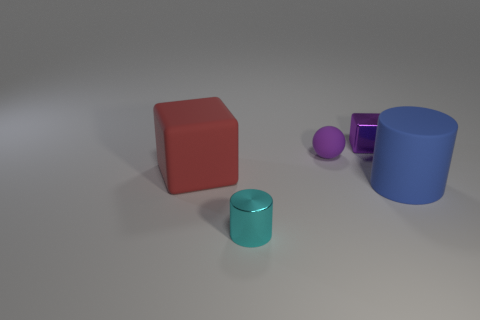Is there anything else that is the same shape as the small matte object?
Ensure brevity in your answer.  No. There is a small metallic thing behind the big cylinder; is its shape the same as the blue object?
Make the answer very short. No. How many cyan metal cylinders have the same size as the metallic block?
Offer a terse response. 1. How many blue matte cylinders are on the right side of the cube that is right of the tiny cyan shiny object?
Keep it short and to the point. 1. Is the thing that is in front of the matte cylinder made of the same material as the blue thing?
Ensure brevity in your answer.  No. Is the material of the cylinder that is in front of the blue cylinder the same as the small thing that is behind the small rubber thing?
Ensure brevity in your answer.  Yes. Is the number of things that are on the right side of the tiny cyan object greater than the number of small cyan things?
Provide a short and direct response. Yes. There is a large rubber object that is to the left of the cylinder that is in front of the blue matte object; what color is it?
Your answer should be very brief. Red. There is a purple metal object that is the same size as the cyan metal thing; what shape is it?
Your answer should be very brief. Cube. There is a tiny metal object that is the same color as the tiny matte sphere; what shape is it?
Offer a very short reply. Cube. 